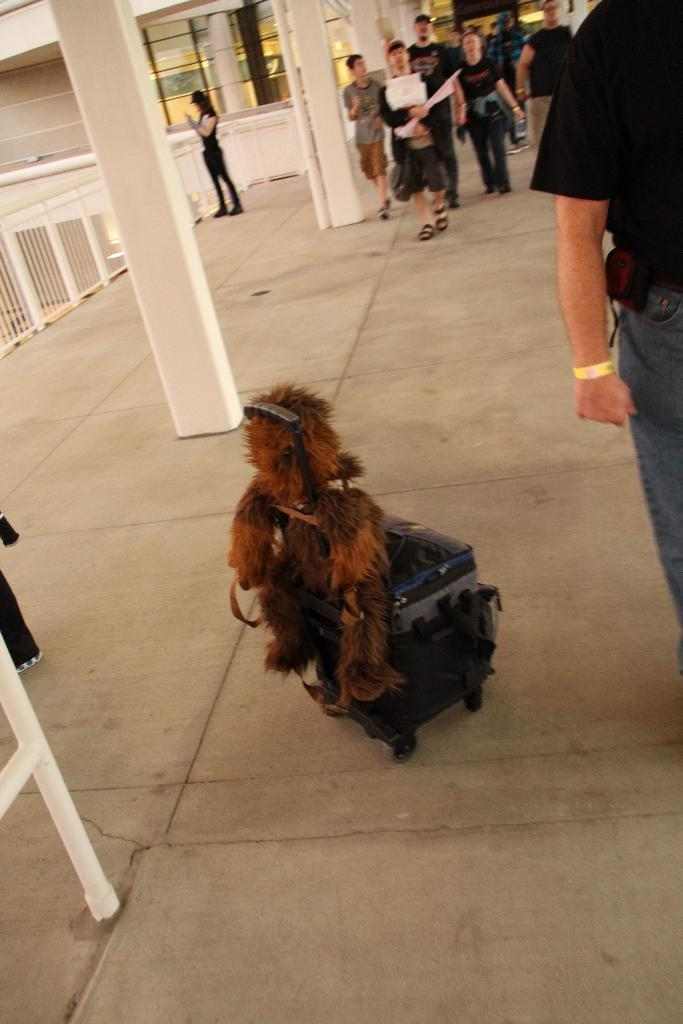What object is placed on the floor in the image? There is a luggage bag on the floor. What are the people in the image doing? There are persons walking in the image. What type of structures can be seen in the image? There are buildings visible in the image. What safety feature is present in the image? Railings are present in the image. How many jellyfish can be seen swimming in the image? There are no jellyfish present in the image; it does not depict a water environment. What type of drain is visible in the image? There is no drain present in the image. 